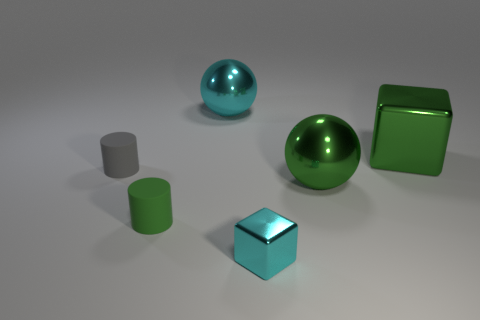Add 1 large purple matte cubes. How many objects exist? 7 Subtract all cylinders. How many objects are left? 4 Add 1 tiny rubber cylinders. How many tiny rubber cylinders are left? 3 Add 6 big matte cylinders. How many big matte cylinders exist? 6 Subtract 0 brown cubes. How many objects are left? 6 Subtract all small cyan blocks. Subtract all big green metallic objects. How many objects are left? 3 